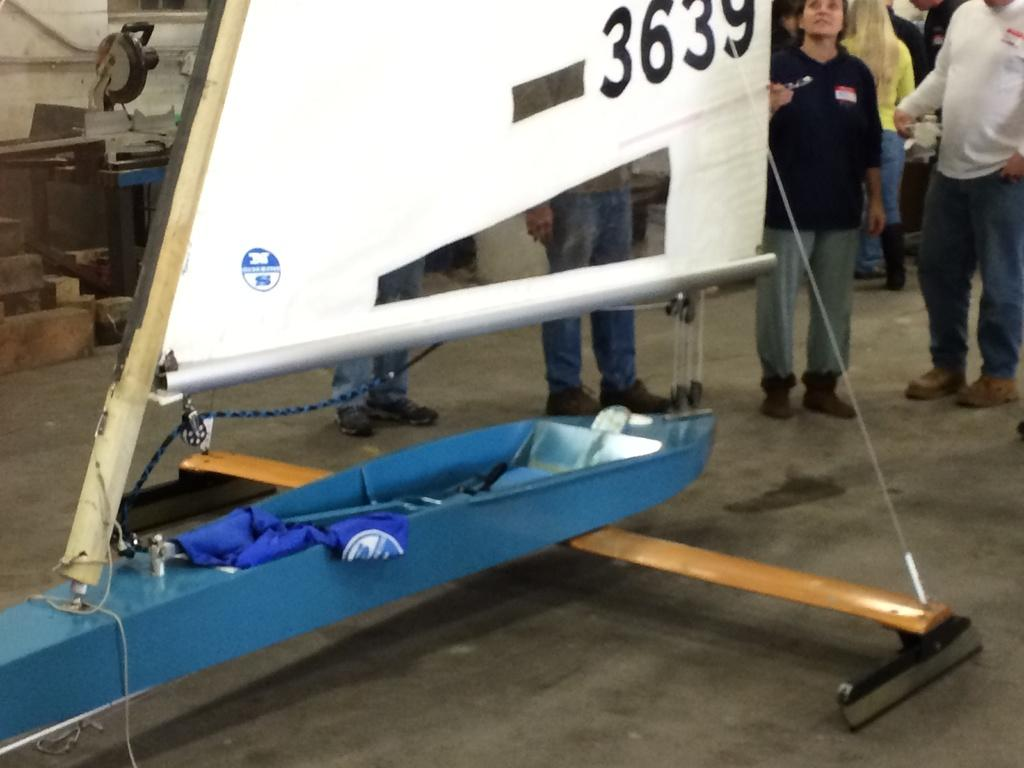<image>
Share a concise interpretation of the image provided. A woman is talking to a group and pointing to an airplane tail with the number 3639 on it. 